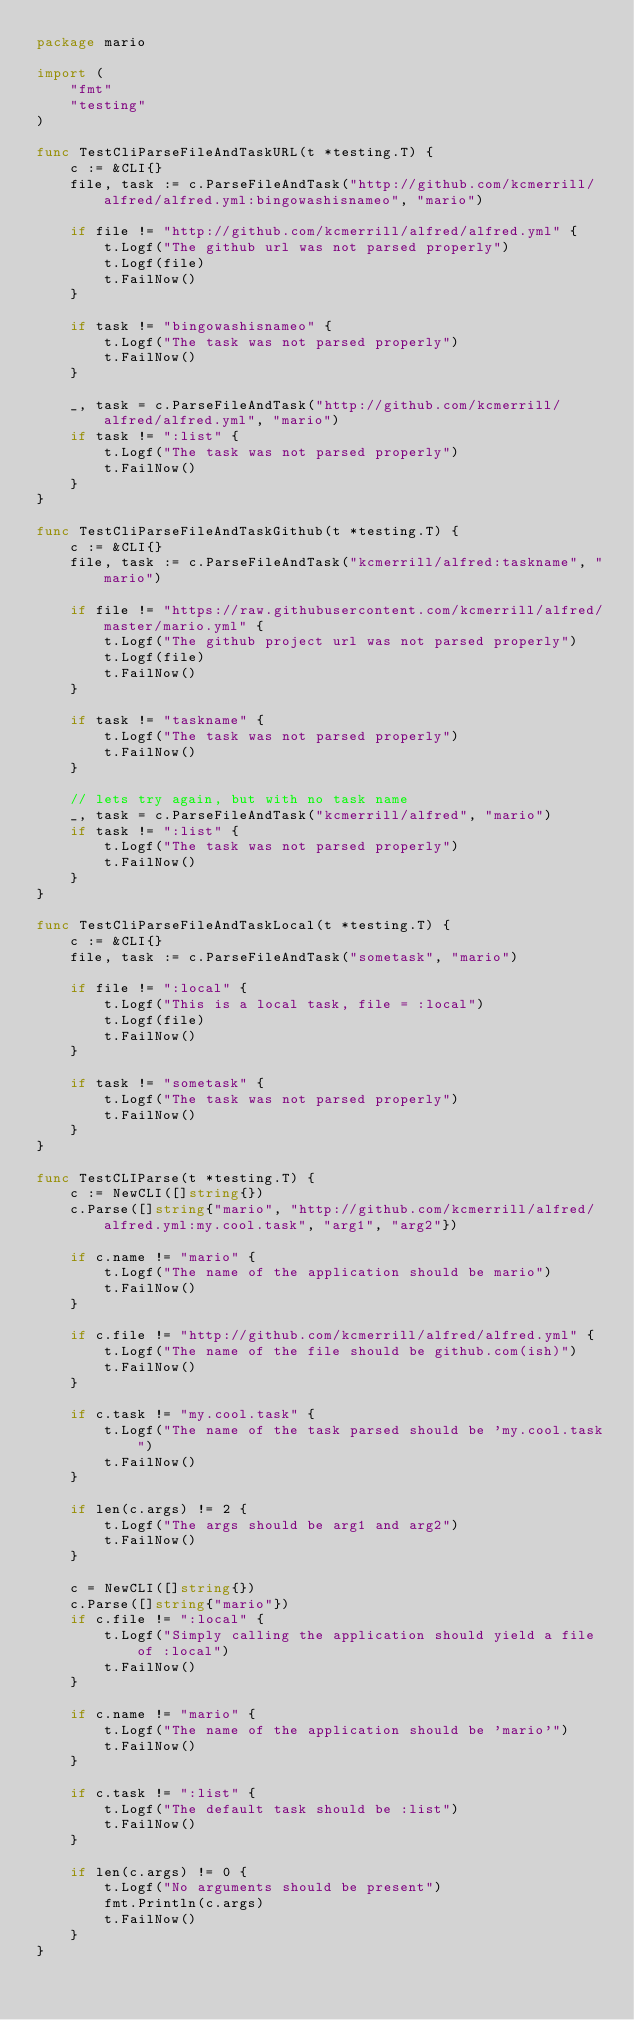<code> <loc_0><loc_0><loc_500><loc_500><_Go_>package mario

import (
	"fmt"
	"testing"
)

func TestCliParseFileAndTaskURL(t *testing.T) {
	c := &CLI{}
	file, task := c.ParseFileAndTask("http://github.com/kcmerrill/alfred/alfred.yml:bingowashisnameo", "mario")

	if file != "http://github.com/kcmerrill/alfred/alfred.yml" {
		t.Logf("The github url was not parsed properly")
		t.Logf(file)
		t.FailNow()
	}

	if task != "bingowashisnameo" {
		t.Logf("The task was not parsed properly")
		t.FailNow()
	}

	_, task = c.ParseFileAndTask("http://github.com/kcmerrill/alfred/alfred.yml", "mario")
	if task != ":list" {
		t.Logf("The task was not parsed properly")
		t.FailNow()
	}
}

func TestCliParseFileAndTaskGithub(t *testing.T) {
	c := &CLI{}
	file, task := c.ParseFileAndTask("kcmerrill/alfred:taskname", "mario")

	if file != "https://raw.githubusercontent.com/kcmerrill/alfred/master/mario.yml" {
		t.Logf("The github project url was not parsed properly")
		t.Logf(file)
		t.FailNow()
	}

	if task != "taskname" {
		t.Logf("The task was not parsed properly")
		t.FailNow()
	}

	// lets try again, but with no task name
	_, task = c.ParseFileAndTask("kcmerrill/alfred", "mario")
	if task != ":list" {
		t.Logf("The task was not parsed properly")
		t.FailNow()
	}
}

func TestCliParseFileAndTaskLocal(t *testing.T) {
	c := &CLI{}
	file, task := c.ParseFileAndTask("sometask", "mario")

	if file != ":local" {
		t.Logf("This is a local task, file = :local")
		t.Logf(file)
		t.FailNow()
	}

	if task != "sometask" {
		t.Logf("The task was not parsed properly")
		t.FailNow()
	}
}

func TestCLIParse(t *testing.T) {
	c := NewCLI([]string{})
	c.Parse([]string{"mario", "http://github.com/kcmerrill/alfred/alfred.yml:my.cool.task", "arg1", "arg2"})

	if c.name != "mario" {
		t.Logf("The name of the application should be mario")
		t.FailNow()
	}

	if c.file != "http://github.com/kcmerrill/alfred/alfred.yml" {
		t.Logf("The name of the file should be github.com(ish)")
		t.FailNow()
	}

	if c.task != "my.cool.task" {
		t.Logf("The name of the task parsed should be 'my.cool.task")
		t.FailNow()
	}

	if len(c.args) != 2 {
		t.Logf("The args should be arg1 and arg2")
		t.FailNow()
	}

	c = NewCLI([]string{})
	c.Parse([]string{"mario"})
	if c.file != ":local" {
		t.Logf("Simply calling the application should yield a file of :local")
		t.FailNow()
	}

	if c.name != "mario" {
		t.Logf("The name of the application should be 'mario'")
		t.FailNow()
	}

	if c.task != ":list" {
		t.Logf("The default task should be :list")
		t.FailNow()
	}

	if len(c.args) != 0 {
		t.Logf("No arguments should be present")
		fmt.Println(c.args)
		t.FailNow()
	}
}
</code> 